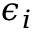<formula> <loc_0><loc_0><loc_500><loc_500>\epsilon _ { i }</formula> 